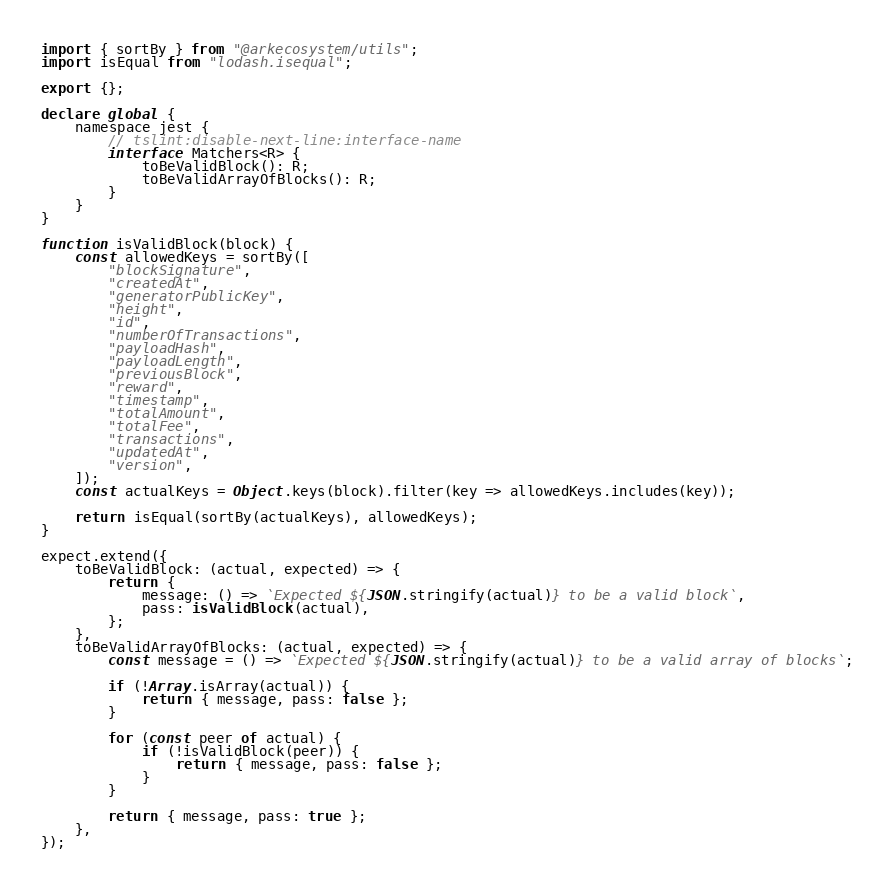Convert code to text. <code><loc_0><loc_0><loc_500><loc_500><_TypeScript_>import { sortBy } from "@arkecosystem/utils";
import isEqual from "lodash.isequal";

export {};

declare global {
    namespace jest {
        // tslint:disable-next-line:interface-name
        interface Matchers<R> {
            toBeValidBlock(): R;
            toBeValidArrayOfBlocks(): R;
        }
    }
}

function isValidBlock(block) {
    const allowedKeys = sortBy([
        "blockSignature",
        "createdAt",
        "generatorPublicKey",
        "height",
        "id",
        "numberOfTransactions",
        "payloadHash",
        "payloadLength",
        "previousBlock",
        "reward",
        "timestamp",
        "totalAmount",
        "totalFee",
        "transactions",
        "updatedAt",
        "version",
    ]);
    const actualKeys = Object.keys(block).filter(key => allowedKeys.includes(key));

    return isEqual(sortBy(actualKeys), allowedKeys);
}

expect.extend({
    toBeValidBlock: (actual, expected) => {
        return {
            message: () => `Expected ${JSON.stringify(actual)} to be a valid block`,
            pass: isValidBlock(actual),
        };
    },
    toBeValidArrayOfBlocks: (actual, expected) => {
        const message = () => `Expected ${JSON.stringify(actual)} to be a valid array of blocks`;

        if (!Array.isArray(actual)) {
            return { message, pass: false };
        }

        for (const peer of actual) {
            if (!isValidBlock(peer)) {
                return { message, pass: false };
            }
        }

        return { message, pass: true };
    },
});
</code> 